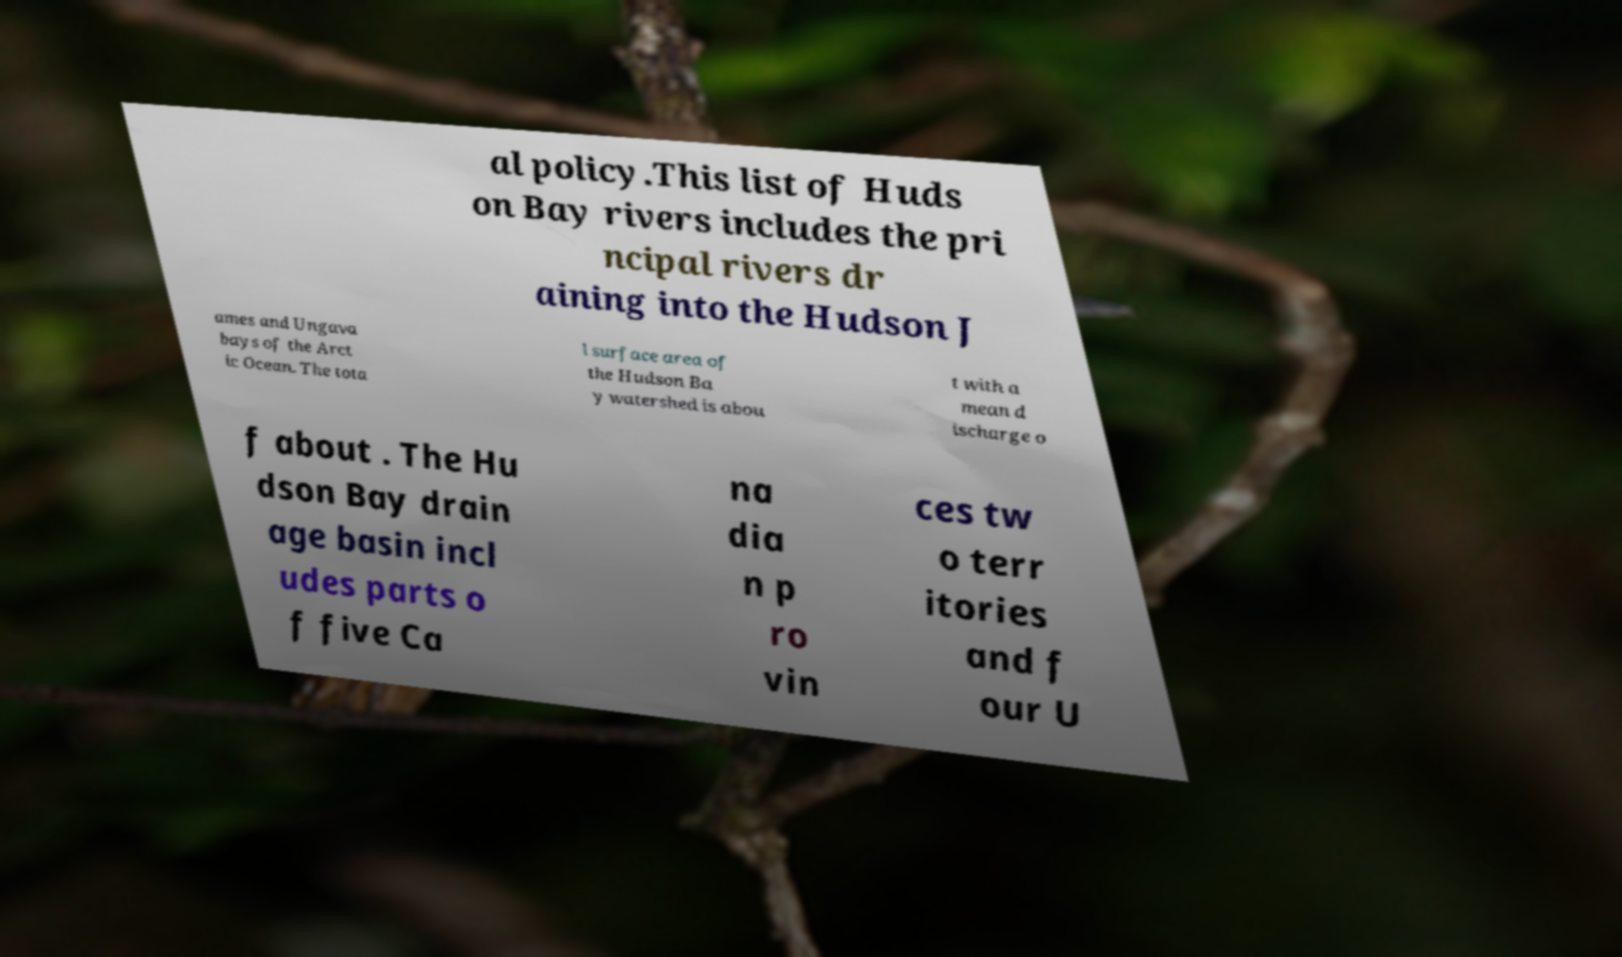I need the written content from this picture converted into text. Can you do that? al policy.This list of Huds on Bay rivers includes the pri ncipal rivers dr aining into the Hudson J ames and Ungava bays of the Arct ic Ocean. The tota l surface area of the Hudson Ba y watershed is abou t with a mean d ischarge o f about . The Hu dson Bay drain age basin incl udes parts o f five Ca na dia n p ro vin ces tw o terr itories and f our U 